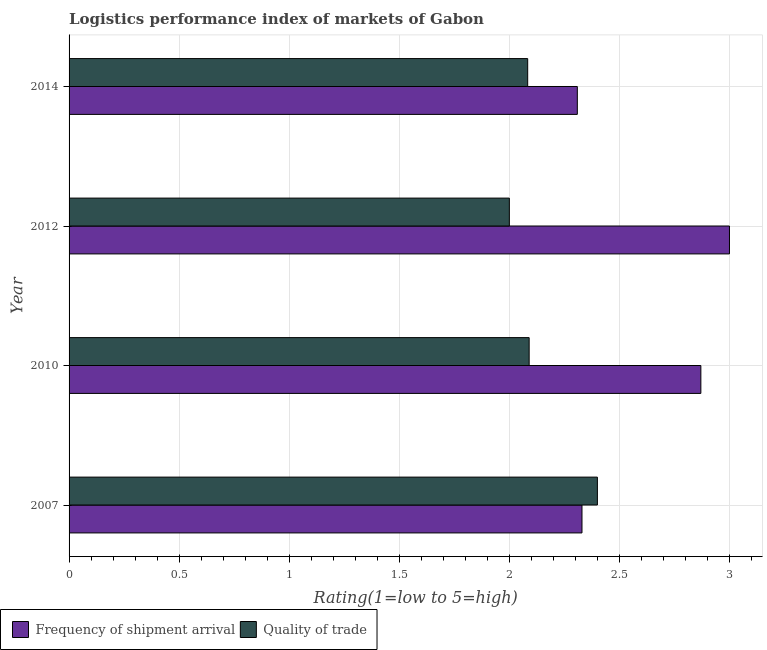How many bars are there on the 2nd tick from the top?
Provide a short and direct response. 2. How many bars are there on the 4th tick from the bottom?
Offer a terse response. 2. In how many cases, is the number of bars for a given year not equal to the number of legend labels?
Give a very brief answer. 0. What is the lpi quality of trade in 2014?
Your answer should be compact. 2.08. Across all years, what is the minimum lpi of frequency of shipment arrival?
Provide a succinct answer. 2.31. In which year was the lpi of frequency of shipment arrival minimum?
Offer a terse response. 2014. What is the total lpi of frequency of shipment arrival in the graph?
Provide a succinct answer. 10.51. What is the difference between the lpi of frequency of shipment arrival in 2007 and that in 2012?
Ensure brevity in your answer.  -0.67. What is the difference between the lpi of frequency of shipment arrival in 2010 and the lpi quality of trade in 2014?
Keep it short and to the point. 0.79. What is the average lpi of frequency of shipment arrival per year?
Provide a short and direct response. 2.63. In the year 2012, what is the difference between the lpi of frequency of shipment arrival and lpi quality of trade?
Keep it short and to the point. 1. In how many years, is the lpi quality of trade greater than 1.8 ?
Provide a succinct answer. 4. What is the ratio of the lpi of frequency of shipment arrival in 2010 to that in 2014?
Provide a short and direct response. 1.24. Is the lpi quality of trade in 2007 less than that in 2010?
Offer a terse response. No. What is the difference between the highest and the second highest lpi of frequency of shipment arrival?
Offer a very short reply. 0.13. What is the difference between the highest and the lowest lpi quality of trade?
Offer a terse response. 0.4. In how many years, is the lpi quality of trade greater than the average lpi quality of trade taken over all years?
Make the answer very short. 1. What does the 2nd bar from the top in 2007 represents?
Ensure brevity in your answer.  Frequency of shipment arrival. What does the 1st bar from the bottom in 2010 represents?
Offer a very short reply. Frequency of shipment arrival. How many bars are there?
Ensure brevity in your answer.  8. How many years are there in the graph?
Provide a short and direct response. 4. Are the values on the major ticks of X-axis written in scientific E-notation?
Your answer should be very brief. No. Does the graph contain any zero values?
Provide a short and direct response. No. Does the graph contain grids?
Provide a short and direct response. Yes. How are the legend labels stacked?
Keep it short and to the point. Horizontal. What is the title of the graph?
Offer a very short reply. Logistics performance index of markets of Gabon. What is the label or title of the X-axis?
Offer a very short reply. Rating(1=low to 5=high). What is the label or title of the Y-axis?
Your answer should be compact. Year. What is the Rating(1=low to 5=high) of Frequency of shipment arrival in 2007?
Offer a terse response. 2.33. What is the Rating(1=low to 5=high) in Quality of trade in 2007?
Provide a succinct answer. 2.4. What is the Rating(1=low to 5=high) in Frequency of shipment arrival in 2010?
Make the answer very short. 2.87. What is the Rating(1=low to 5=high) in Quality of trade in 2010?
Make the answer very short. 2.09. What is the Rating(1=low to 5=high) of Quality of trade in 2012?
Your response must be concise. 2. What is the Rating(1=low to 5=high) of Frequency of shipment arrival in 2014?
Keep it short and to the point. 2.31. What is the Rating(1=low to 5=high) in Quality of trade in 2014?
Make the answer very short. 2.08. Across all years, what is the minimum Rating(1=low to 5=high) in Frequency of shipment arrival?
Your answer should be compact. 2.31. What is the total Rating(1=low to 5=high) in Frequency of shipment arrival in the graph?
Give a very brief answer. 10.51. What is the total Rating(1=low to 5=high) in Quality of trade in the graph?
Your answer should be compact. 8.57. What is the difference between the Rating(1=low to 5=high) of Frequency of shipment arrival in 2007 and that in 2010?
Your answer should be compact. -0.54. What is the difference between the Rating(1=low to 5=high) in Quality of trade in 2007 and that in 2010?
Provide a short and direct response. 0.31. What is the difference between the Rating(1=low to 5=high) of Frequency of shipment arrival in 2007 and that in 2012?
Your answer should be compact. -0.67. What is the difference between the Rating(1=low to 5=high) in Quality of trade in 2007 and that in 2012?
Offer a very short reply. 0.4. What is the difference between the Rating(1=low to 5=high) in Frequency of shipment arrival in 2007 and that in 2014?
Your response must be concise. 0.02. What is the difference between the Rating(1=low to 5=high) in Quality of trade in 2007 and that in 2014?
Your response must be concise. 0.32. What is the difference between the Rating(1=low to 5=high) of Frequency of shipment arrival in 2010 and that in 2012?
Provide a succinct answer. -0.13. What is the difference between the Rating(1=low to 5=high) of Quality of trade in 2010 and that in 2012?
Your answer should be compact. 0.09. What is the difference between the Rating(1=low to 5=high) in Frequency of shipment arrival in 2010 and that in 2014?
Your answer should be compact. 0.56. What is the difference between the Rating(1=low to 5=high) in Quality of trade in 2010 and that in 2014?
Your answer should be very brief. 0.01. What is the difference between the Rating(1=low to 5=high) in Frequency of shipment arrival in 2012 and that in 2014?
Ensure brevity in your answer.  0.69. What is the difference between the Rating(1=low to 5=high) of Quality of trade in 2012 and that in 2014?
Provide a short and direct response. -0.08. What is the difference between the Rating(1=low to 5=high) in Frequency of shipment arrival in 2007 and the Rating(1=low to 5=high) in Quality of trade in 2010?
Make the answer very short. 0.24. What is the difference between the Rating(1=low to 5=high) in Frequency of shipment arrival in 2007 and the Rating(1=low to 5=high) in Quality of trade in 2012?
Ensure brevity in your answer.  0.33. What is the difference between the Rating(1=low to 5=high) in Frequency of shipment arrival in 2007 and the Rating(1=low to 5=high) in Quality of trade in 2014?
Provide a short and direct response. 0.25. What is the difference between the Rating(1=low to 5=high) of Frequency of shipment arrival in 2010 and the Rating(1=low to 5=high) of Quality of trade in 2012?
Provide a short and direct response. 0.87. What is the difference between the Rating(1=low to 5=high) of Frequency of shipment arrival in 2010 and the Rating(1=low to 5=high) of Quality of trade in 2014?
Your answer should be very brief. 0.79. What is the average Rating(1=low to 5=high) in Frequency of shipment arrival per year?
Your response must be concise. 2.63. What is the average Rating(1=low to 5=high) in Quality of trade per year?
Your answer should be compact. 2.14. In the year 2007, what is the difference between the Rating(1=low to 5=high) in Frequency of shipment arrival and Rating(1=low to 5=high) in Quality of trade?
Your answer should be compact. -0.07. In the year 2010, what is the difference between the Rating(1=low to 5=high) in Frequency of shipment arrival and Rating(1=low to 5=high) in Quality of trade?
Provide a short and direct response. 0.78. In the year 2014, what is the difference between the Rating(1=low to 5=high) in Frequency of shipment arrival and Rating(1=low to 5=high) in Quality of trade?
Give a very brief answer. 0.23. What is the ratio of the Rating(1=low to 5=high) of Frequency of shipment arrival in 2007 to that in 2010?
Your response must be concise. 0.81. What is the ratio of the Rating(1=low to 5=high) of Quality of trade in 2007 to that in 2010?
Ensure brevity in your answer.  1.15. What is the ratio of the Rating(1=low to 5=high) of Frequency of shipment arrival in 2007 to that in 2012?
Offer a terse response. 0.78. What is the ratio of the Rating(1=low to 5=high) of Frequency of shipment arrival in 2007 to that in 2014?
Make the answer very short. 1.01. What is the ratio of the Rating(1=low to 5=high) of Quality of trade in 2007 to that in 2014?
Your response must be concise. 1.15. What is the ratio of the Rating(1=low to 5=high) in Frequency of shipment arrival in 2010 to that in 2012?
Offer a very short reply. 0.96. What is the ratio of the Rating(1=low to 5=high) in Quality of trade in 2010 to that in 2012?
Your answer should be compact. 1.04. What is the ratio of the Rating(1=low to 5=high) in Frequency of shipment arrival in 2010 to that in 2014?
Make the answer very short. 1.24. What is the ratio of the Rating(1=low to 5=high) of Quality of trade in 2010 to that in 2014?
Make the answer very short. 1. What is the ratio of the Rating(1=low to 5=high) in Frequency of shipment arrival in 2012 to that in 2014?
Your answer should be compact. 1.3. What is the ratio of the Rating(1=low to 5=high) in Quality of trade in 2012 to that in 2014?
Provide a succinct answer. 0.96. What is the difference between the highest and the second highest Rating(1=low to 5=high) of Frequency of shipment arrival?
Make the answer very short. 0.13. What is the difference between the highest and the second highest Rating(1=low to 5=high) of Quality of trade?
Offer a terse response. 0.31. What is the difference between the highest and the lowest Rating(1=low to 5=high) in Frequency of shipment arrival?
Keep it short and to the point. 0.69. What is the difference between the highest and the lowest Rating(1=low to 5=high) in Quality of trade?
Offer a very short reply. 0.4. 